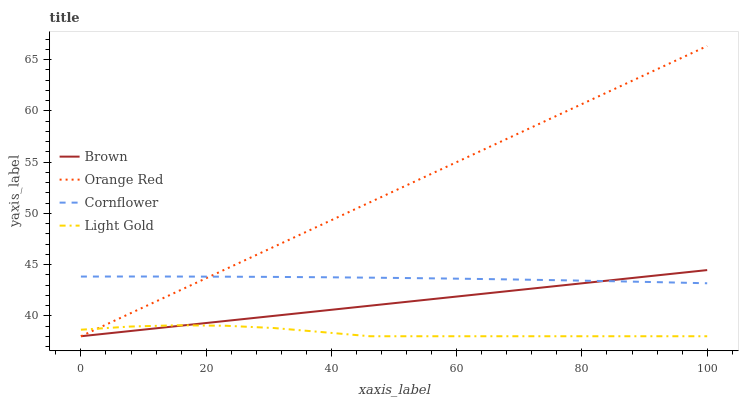Does Light Gold have the minimum area under the curve?
Answer yes or no. Yes. Does Orange Red have the maximum area under the curve?
Answer yes or no. Yes. Does Orange Red have the minimum area under the curve?
Answer yes or no. No. Does Light Gold have the maximum area under the curve?
Answer yes or no. No. Is Brown the smoothest?
Answer yes or no. Yes. Is Light Gold the roughest?
Answer yes or no. Yes. Is Orange Red the smoothest?
Answer yes or no. No. Is Orange Red the roughest?
Answer yes or no. No. Does Brown have the lowest value?
Answer yes or no. Yes. Does Cornflower have the lowest value?
Answer yes or no. No. Does Orange Red have the highest value?
Answer yes or no. Yes. Does Light Gold have the highest value?
Answer yes or no. No. Is Light Gold less than Cornflower?
Answer yes or no. Yes. Is Cornflower greater than Light Gold?
Answer yes or no. Yes. Does Orange Red intersect Brown?
Answer yes or no. Yes. Is Orange Red less than Brown?
Answer yes or no. No. Is Orange Red greater than Brown?
Answer yes or no. No. Does Light Gold intersect Cornflower?
Answer yes or no. No. 